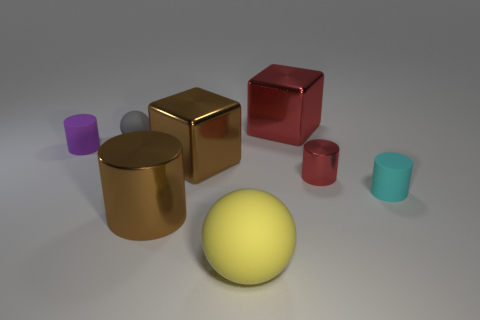Subtract 1 cylinders. How many cylinders are left? 3 Add 2 big blocks. How many objects exist? 10 Subtract all spheres. How many objects are left? 6 Subtract 0 gray blocks. How many objects are left? 8 Subtract all tiny objects. Subtract all big shiny cylinders. How many objects are left? 3 Add 2 metallic objects. How many metallic objects are left? 6 Add 8 small purple matte blocks. How many small purple matte blocks exist? 8 